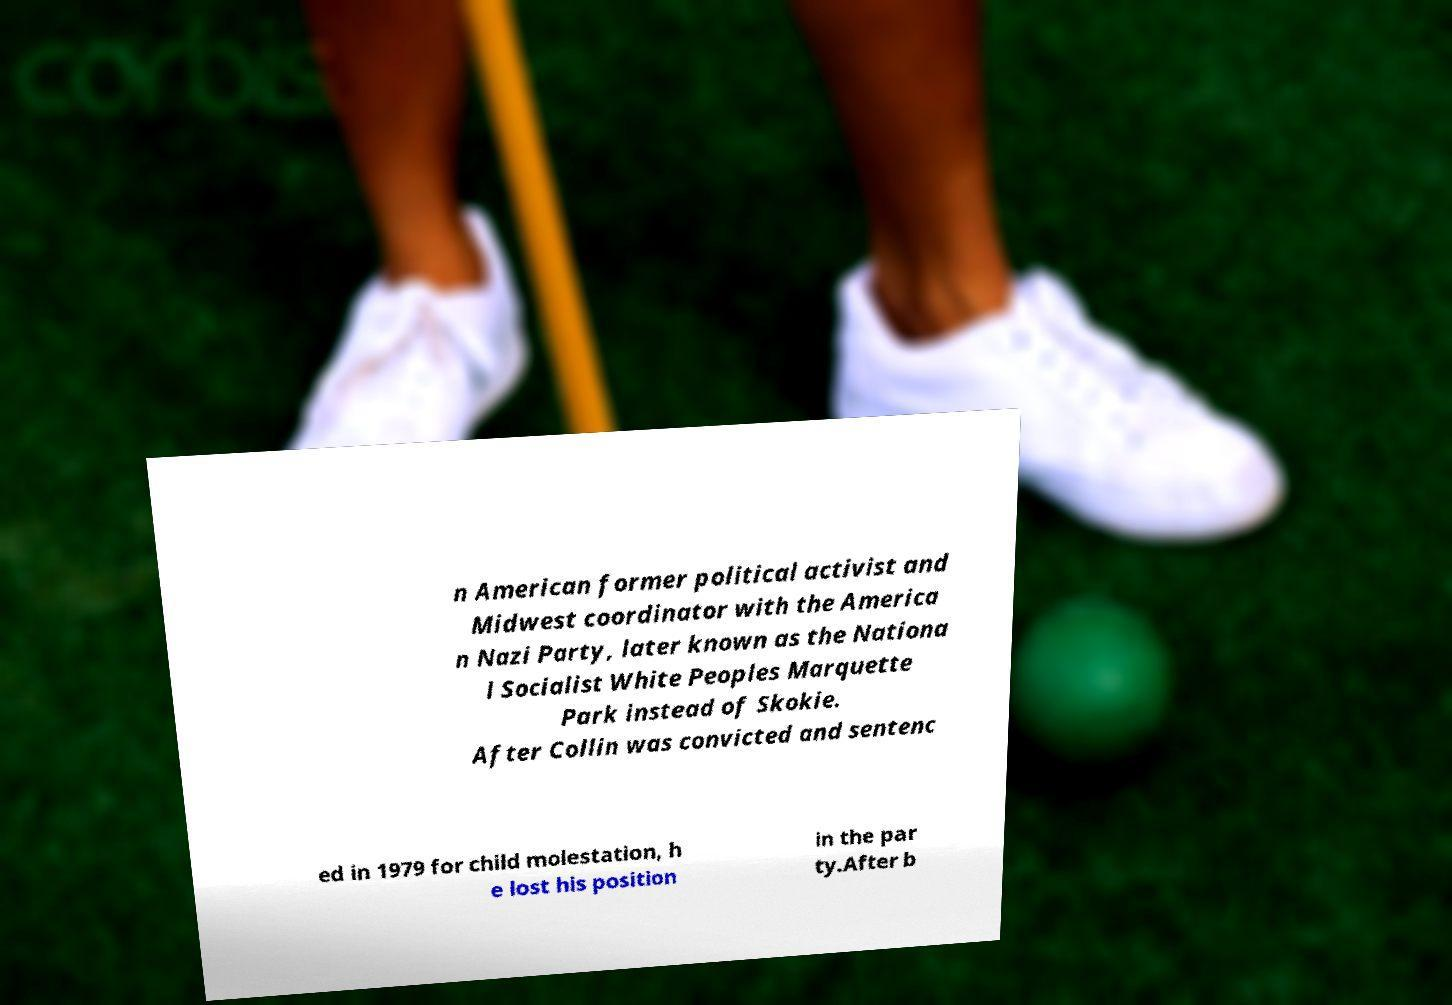Could you assist in decoding the text presented in this image and type it out clearly? n American former political activist and Midwest coordinator with the America n Nazi Party, later known as the Nationa l Socialist White Peoples Marquette Park instead of Skokie. After Collin was convicted and sentenc ed in 1979 for child molestation, h e lost his position in the par ty.After b 